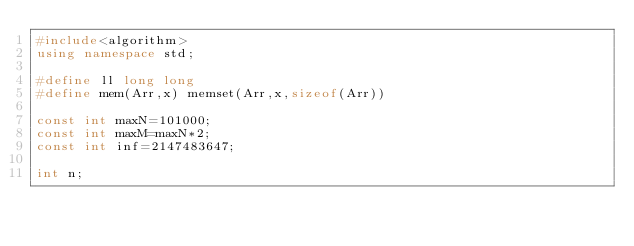Convert code to text. <code><loc_0><loc_0><loc_500><loc_500><_C++_>#include<algorithm>
using namespace std;

#define ll long long
#define mem(Arr,x) memset(Arr,x,sizeof(Arr))

const int maxN=101000;
const int maxM=maxN*2;
const int inf=2147483647;

int n;</code> 